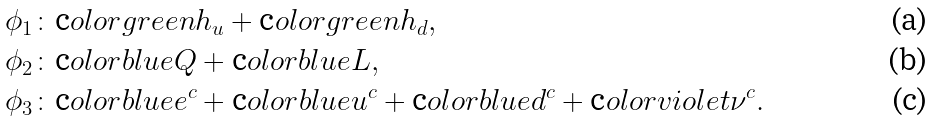<formula> <loc_0><loc_0><loc_500><loc_500>\phi _ { 1 } & \colon \text  color{green} { h _ { u } } + \text  color{green} { h _ { d } } , \\ \phi _ { 2 } & \colon \text  color{blue} { Q } + \text  color{blue} { L } , \\ \phi _ { 3 } & \colon \text  color{blue} { e ^ { c } } + \text  color{blue} { u ^ { c } } + \text  color{blue} { d ^ { c } } + \text  color{violet} { \nu ^ { c } } .</formula> 